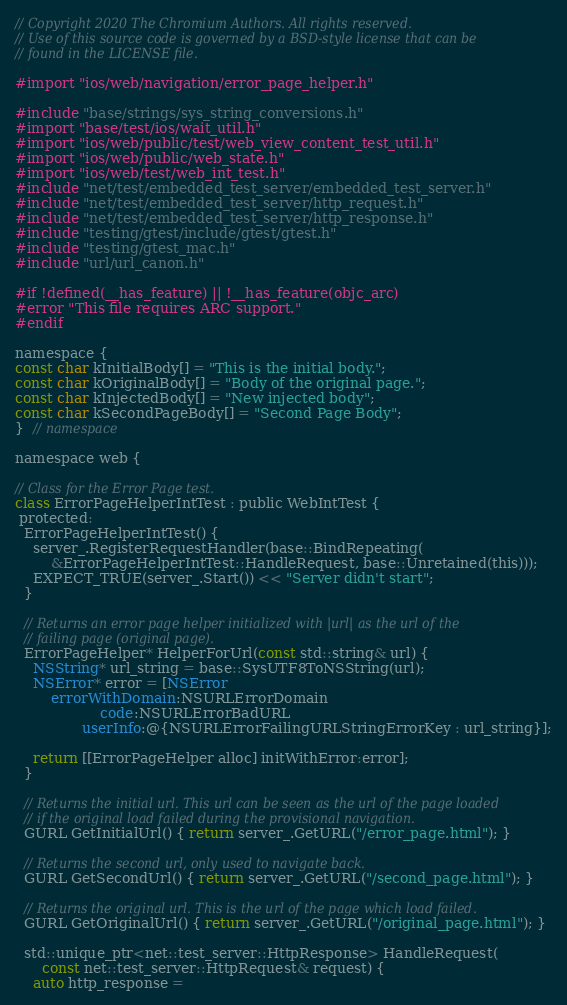Convert code to text. <code><loc_0><loc_0><loc_500><loc_500><_ObjectiveC_>// Copyright 2020 The Chromium Authors. All rights reserved.
// Use of this source code is governed by a BSD-style license that can be
// found in the LICENSE file.

#import "ios/web/navigation/error_page_helper.h"

#include "base/strings/sys_string_conversions.h"
#import "base/test/ios/wait_util.h"
#import "ios/web/public/test/web_view_content_test_util.h"
#import "ios/web/public/web_state.h"
#import "ios/web/test/web_int_test.h"
#include "net/test/embedded_test_server/embedded_test_server.h"
#include "net/test/embedded_test_server/http_request.h"
#include "net/test/embedded_test_server/http_response.h"
#include "testing/gtest/include/gtest/gtest.h"
#include "testing/gtest_mac.h"
#include "url/url_canon.h"

#if !defined(__has_feature) || !__has_feature(objc_arc)
#error "This file requires ARC support."
#endif

namespace {
const char kInitialBody[] = "This is the initial body.";
const char kOriginalBody[] = "Body of the original page.";
const char kInjectedBody[] = "New injected body";
const char kSecondPageBody[] = "Second Page Body";
}  // namespace

namespace web {

// Class for the Error Page test.
class ErrorPageHelperIntTest : public WebIntTest {
 protected:
  ErrorPageHelperIntTest() {
    server_.RegisterRequestHandler(base::BindRepeating(
        &ErrorPageHelperIntTest::HandleRequest, base::Unretained(this)));
    EXPECT_TRUE(server_.Start()) << "Server didn't start";
  }

  // Returns an error page helper initialized with |url| as the url of the
  // failing page (original page).
  ErrorPageHelper* HelperForUrl(const std::string& url) {
    NSString* url_string = base::SysUTF8ToNSString(url);
    NSError* error = [NSError
        errorWithDomain:NSURLErrorDomain
                   code:NSURLErrorBadURL
               userInfo:@{NSURLErrorFailingURLStringErrorKey : url_string}];

    return [[ErrorPageHelper alloc] initWithError:error];
  }

  // Returns the initial url. This url can be seen as the url of the page loaded
  // if the original load failed during the provisional navigation.
  GURL GetInitialUrl() { return server_.GetURL("/error_page.html"); }

  // Returns the second url, only used to navigate back.
  GURL GetSecondUrl() { return server_.GetURL("/second_page.html"); }

  // Returns the original url. This is the url of the page which load failed.
  GURL GetOriginalUrl() { return server_.GetURL("/original_page.html"); }

  std::unique_ptr<net::test_server::HttpResponse> HandleRequest(
      const net::test_server::HttpRequest& request) {
    auto http_response =</code> 